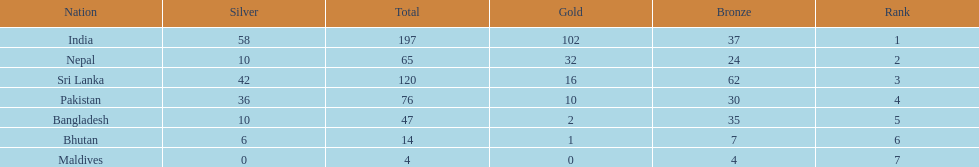What is the difference between the nation with the most medals and the nation with the least amount of medals? 193. 